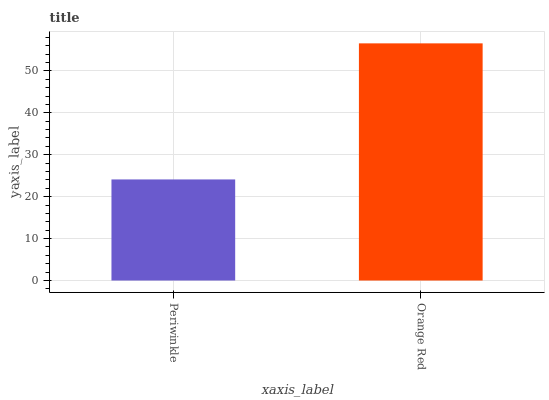Is Periwinkle the minimum?
Answer yes or no. Yes. Is Orange Red the maximum?
Answer yes or no. Yes. Is Orange Red the minimum?
Answer yes or no. No. Is Orange Red greater than Periwinkle?
Answer yes or no. Yes. Is Periwinkle less than Orange Red?
Answer yes or no. Yes. Is Periwinkle greater than Orange Red?
Answer yes or no. No. Is Orange Red less than Periwinkle?
Answer yes or no. No. Is Orange Red the high median?
Answer yes or no. Yes. Is Periwinkle the low median?
Answer yes or no. Yes. Is Periwinkle the high median?
Answer yes or no. No. Is Orange Red the low median?
Answer yes or no. No. 